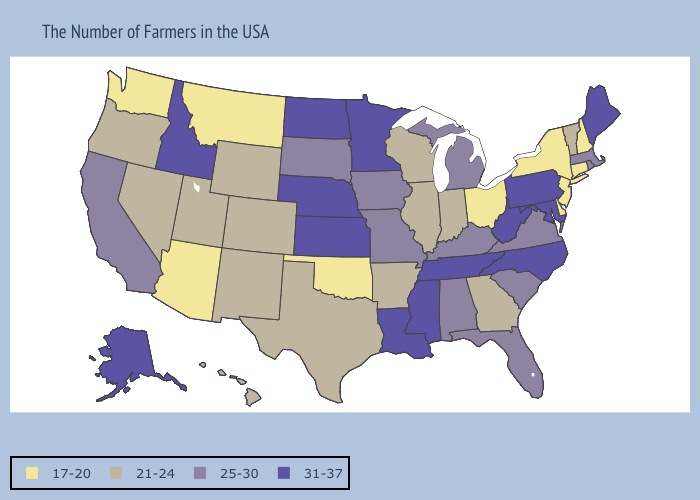Name the states that have a value in the range 25-30?
Be succinct. Massachusetts, Rhode Island, Virginia, South Carolina, Florida, Michigan, Kentucky, Alabama, Missouri, Iowa, South Dakota, California. Does Louisiana have a higher value than Minnesota?
Give a very brief answer. No. What is the value of Oregon?
Give a very brief answer. 21-24. What is the highest value in the South ?
Concise answer only. 31-37. Does the first symbol in the legend represent the smallest category?
Be succinct. Yes. What is the highest value in the USA?
Quick response, please. 31-37. What is the value of Illinois?
Short answer required. 21-24. Does the first symbol in the legend represent the smallest category?
Keep it brief. Yes. Does Vermont have the highest value in the USA?
Quick response, please. No. What is the lowest value in the Northeast?
Be succinct. 17-20. What is the highest value in the USA?
Answer briefly. 31-37. How many symbols are there in the legend?
Concise answer only. 4. What is the highest value in states that border West Virginia?
Keep it brief. 31-37. Does Delaware have the lowest value in the South?
Concise answer only. Yes. What is the value of Illinois?
Give a very brief answer. 21-24. 